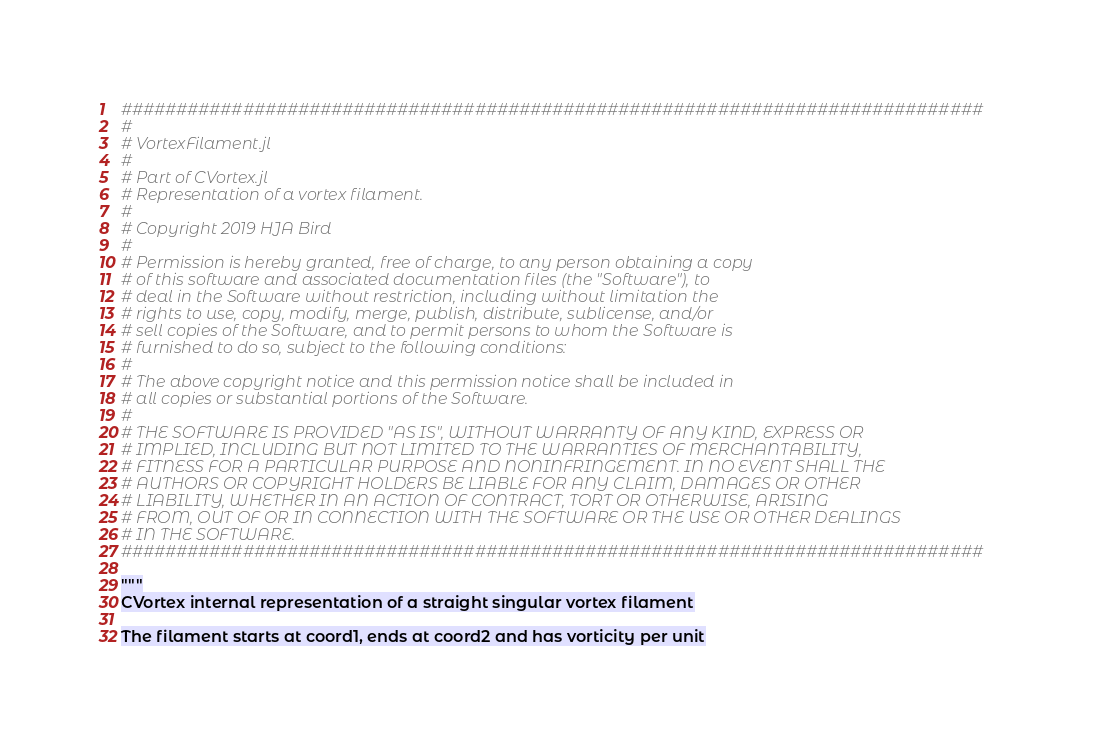<code> <loc_0><loc_0><loc_500><loc_500><_Julia_>##############################################################################
#
# VortexFilament.jl
#
# Part of CVortex.jl
# Representation of a vortex filament.
#
# Copyright 2019 HJA Bird
#
# Permission is hereby granted, free of charge, to any person obtaining a copy
# of this software and associated documentation files (the "Software"), to 
# deal in the Software without restriction, including without limitation the 
# rights to use, copy, modify, merge, publish, distribute, sublicense, and/or
# sell copies of the Software, and to permit persons to whom the Software is 
# furnished to do so, subject to the following conditions:
#
# The above copyright notice and this permission notice shall be included in 
# all copies or substantial portions of the Software.
#
# THE SOFTWARE IS PROVIDED "AS IS", WITHOUT WARRANTY OF ANY KIND, EXPRESS OR 
# IMPLIED, INCLUDING BUT NOT LIMITED TO THE WARRANTIES OF MERCHANTABILITY, 
# FITNESS FOR A PARTICULAR PURPOSE AND NONINFRINGEMENT. IN NO EVENT SHALL THE 
# AUTHORS OR COPYRIGHT HOLDERS BE LIABLE FOR ANY CLAIM, DAMAGES OR OTHER 
# LIABILITY, WHETHER IN AN ACTION OF CONTRACT, TORT OR OTHERWISE, ARISING 
# FROM, OUT OF OR IN CONNECTION WITH THE SOFTWARE OR THE USE OR OTHER DEALINGS
# IN THE SOFTWARE.
##############################################################################

"""
CVortex internal representation of a straight singular vortex filament

The filament starts at coord1, ends at coord2 and has vorticity per unit</code> 